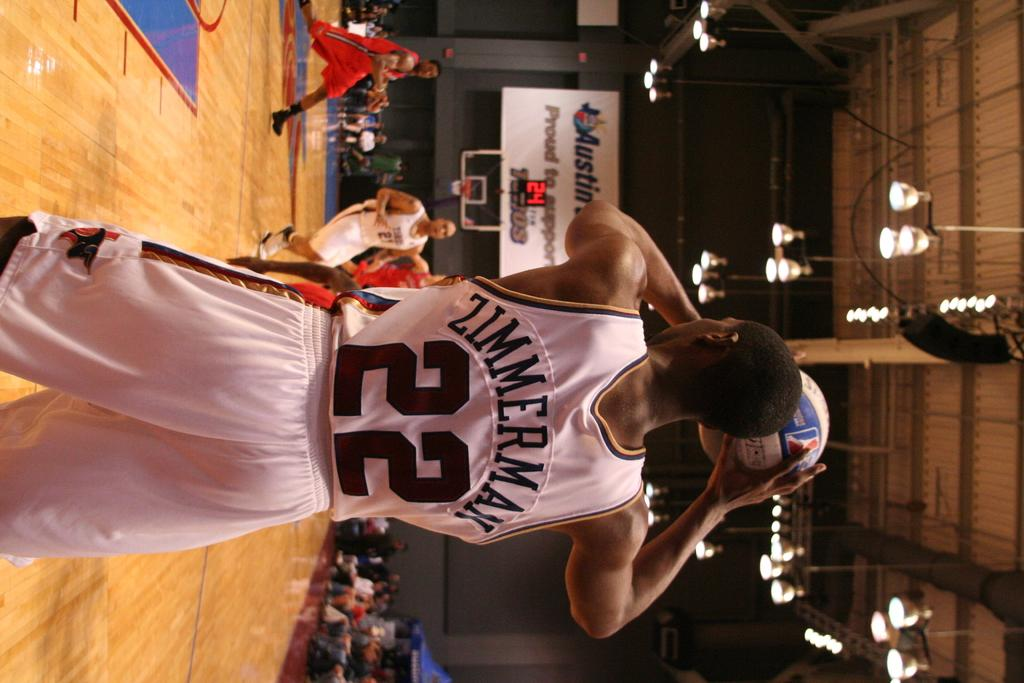<image>
Describe the image concisely. Basketball player Zimmerman number 22 prepares to throw the ball. 